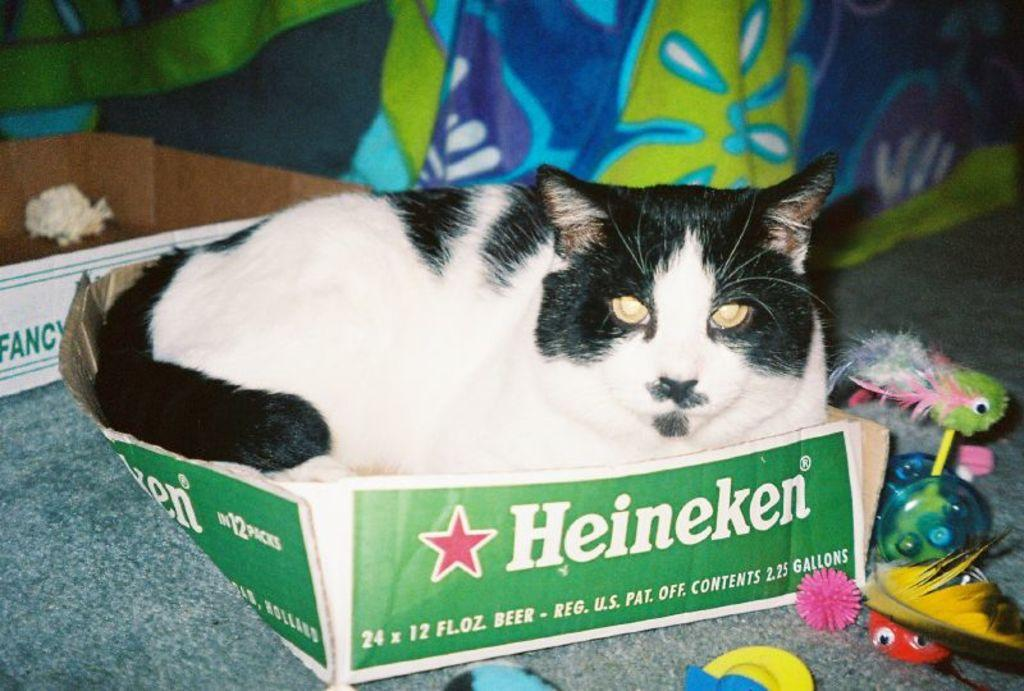Provide a one-sentence caption for the provided image. A black and white cat sitting inside of a box made for Heineken beers. 